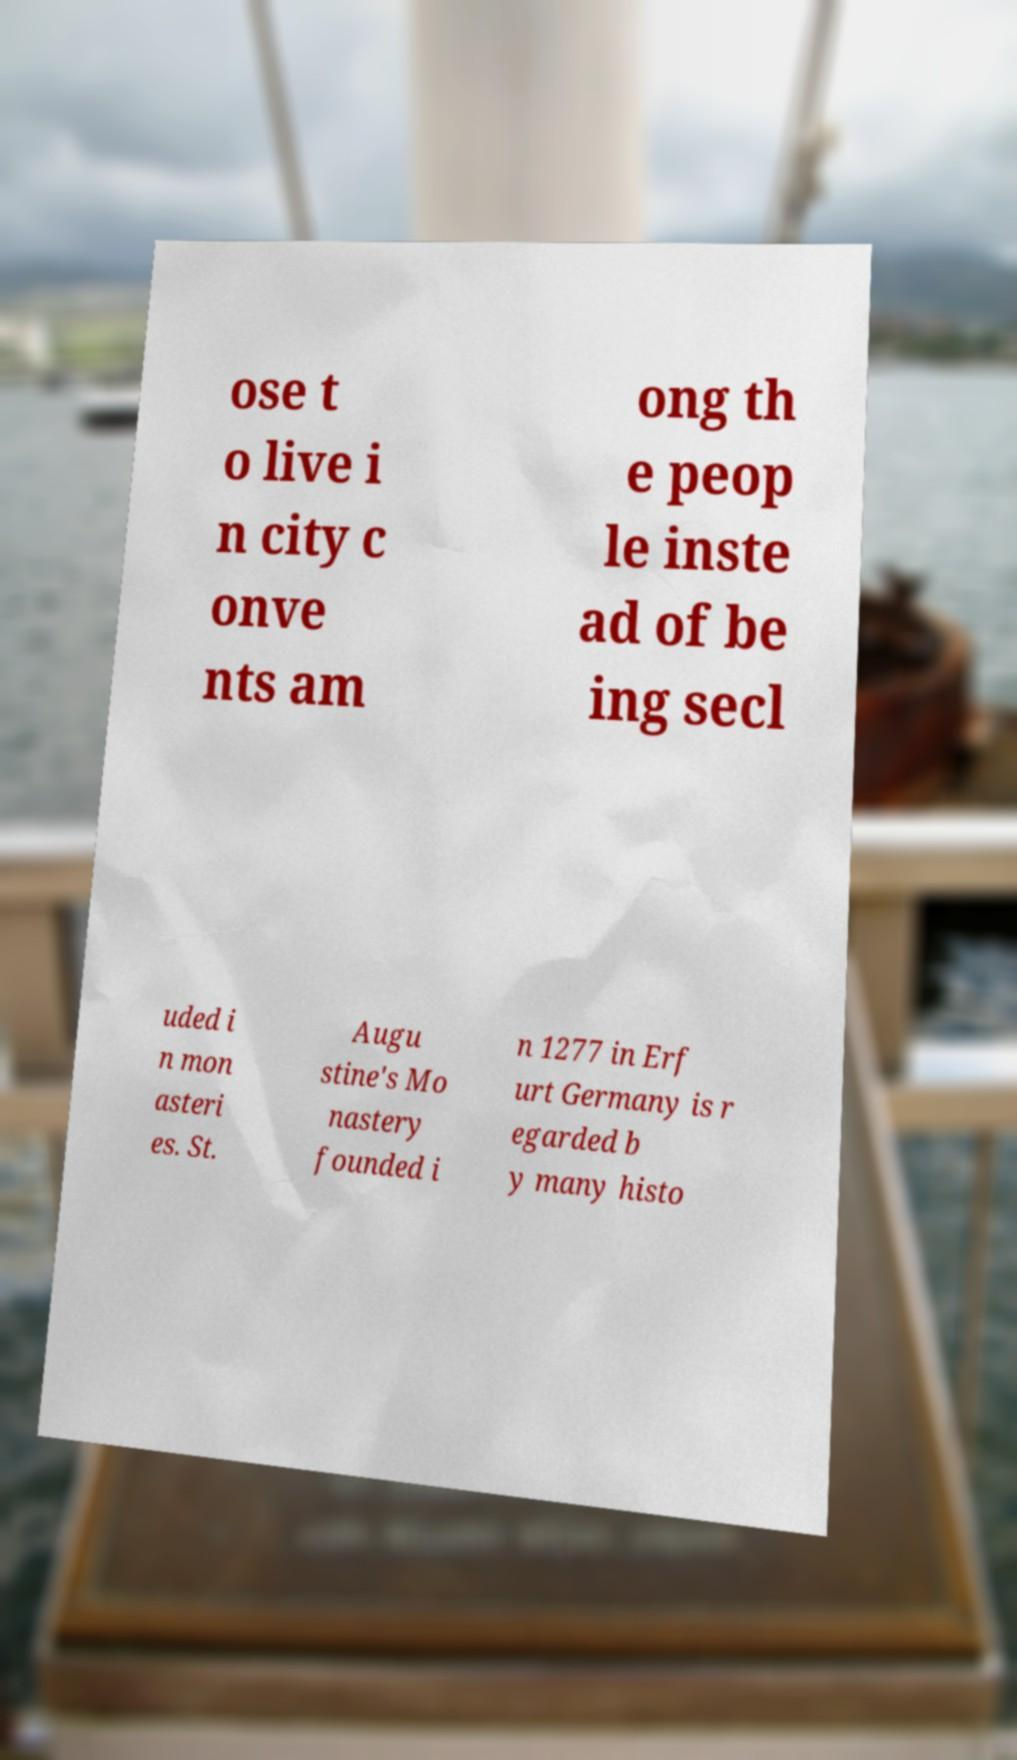There's text embedded in this image that I need extracted. Can you transcribe it verbatim? ose t o live i n city c onve nts am ong th e peop le inste ad of be ing secl uded i n mon asteri es. St. Augu stine's Mo nastery founded i n 1277 in Erf urt Germany is r egarded b y many histo 